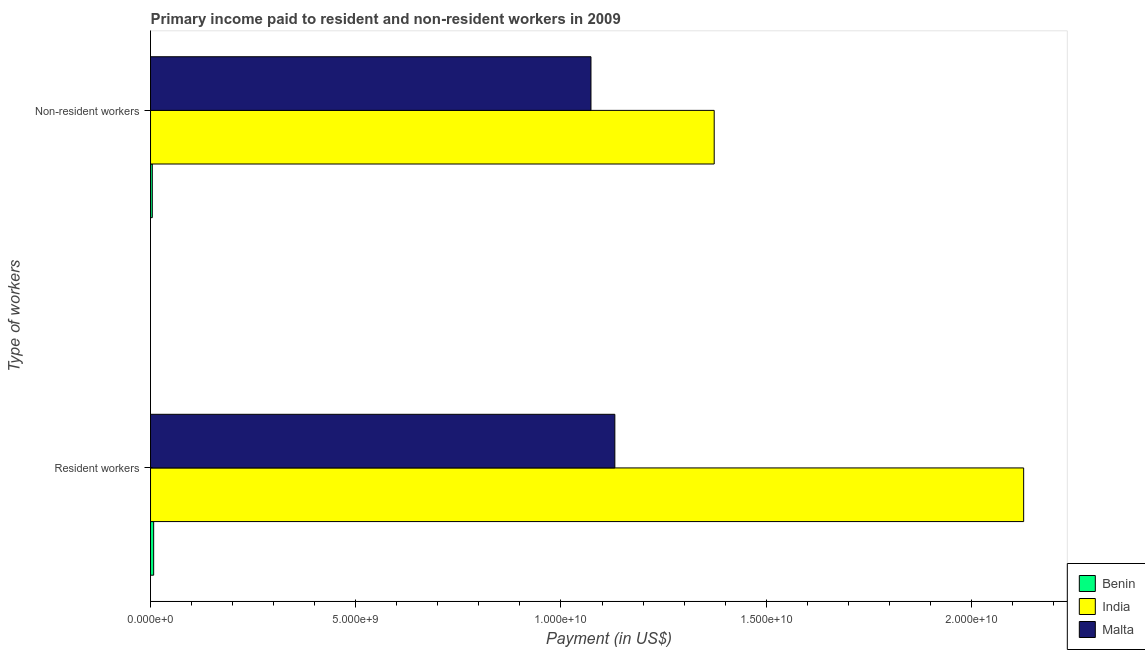Are the number of bars per tick equal to the number of legend labels?
Give a very brief answer. Yes. Are the number of bars on each tick of the Y-axis equal?
Your answer should be compact. Yes. How many bars are there on the 1st tick from the top?
Offer a terse response. 3. What is the label of the 2nd group of bars from the top?
Give a very brief answer. Resident workers. What is the payment made to resident workers in Malta?
Your answer should be compact. 1.13e+1. Across all countries, what is the maximum payment made to non-resident workers?
Provide a succinct answer. 1.37e+1. Across all countries, what is the minimum payment made to non-resident workers?
Offer a terse response. 4.31e+07. In which country was the payment made to non-resident workers minimum?
Your answer should be compact. Benin. What is the total payment made to resident workers in the graph?
Your answer should be compact. 3.27e+1. What is the difference between the payment made to resident workers in Malta and that in Benin?
Provide a short and direct response. 1.12e+1. What is the difference between the payment made to resident workers in India and the payment made to non-resident workers in Malta?
Your response must be concise. 1.05e+1. What is the average payment made to resident workers per country?
Give a very brief answer. 1.09e+1. What is the difference between the payment made to non-resident workers and payment made to resident workers in Malta?
Provide a succinct answer. -5.82e+08. What is the ratio of the payment made to resident workers in Malta to that in Benin?
Your response must be concise. 148.67. Is the payment made to non-resident workers in Benin less than that in Malta?
Your response must be concise. Yes. In how many countries, is the payment made to resident workers greater than the average payment made to resident workers taken over all countries?
Your response must be concise. 2. What does the 3rd bar from the bottom in Non-resident workers represents?
Offer a terse response. Malta. How many bars are there?
Your answer should be very brief. 6. What is the difference between two consecutive major ticks on the X-axis?
Give a very brief answer. 5.00e+09. Does the graph contain grids?
Ensure brevity in your answer.  No. What is the title of the graph?
Your answer should be compact. Primary income paid to resident and non-resident workers in 2009. What is the label or title of the X-axis?
Your answer should be very brief. Payment (in US$). What is the label or title of the Y-axis?
Make the answer very short. Type of workers. What is the Payment (in US$) of Benin in Resident workers?
Your answer should be compact. 7.61e+07. What is the Payment (in US$) of India in Resident workers?
Provide a succinct answer. 2.13e+1. What is the Payment (in US$) in Malta in Resident workers?
Offer a terse response. 1.13e+1. What is the Payment (in US$) in Benin in Non-resident workers?
Offer a terse response. 4.31e+07. What is the Payment (in US$) of India in Non-resident workers?
Give a very brief answer. 1.37e+1. What is the Payment (in US$) in Malta in Non-resident workers?
Make the answer very short. 1.07e+1. Across all Type of workers, what is the maximum Payment (in US$) in Benin?
Offer a terse response. 7.61e+07. Across all Type of workers, what is the maximum Payment (in US$) of India?
Make the answer very short. 2.13e+1. Across all Type of workers, what is the maximum Payment (in US$) in Malta?
Give a very brief answer. 1.13e+1. Across all Type of workers, what is the minimum Payment (in US$) in Benin?
Keep it short and to the point. 4.31e+07. Across all Type of workers, what is the minimum Payment (in US$) of India?
Give a very brief answer. 1.37e+1. Across all Type of workers, what is the minimum Payment (in US$) of Malta?
Ensure brevity in your answer.  1.07e+1. What is the total Payment (in US$) of Benin in the graph?
Provide a succinct answer. 1.19e+08. What is the total Payment (in US$) of India in the graph?
Provide a short and direct response. 3.50e+1. What is the total Payment (in US$) in Malta in the graph?
Provide a succinct answer. 2.20e+1. What is the difference between the Payment (in US$) in Benin in Resident workers and that in Non-resident workers?
Offer a very short reply. 3.30e+07. What is the difference between the Payment (in US$) in India in Resident workers and that in Non-resident workers?
Offer a very short reply. 7.54e+09. What is the difference between the Payment (in US$) in Malta in Resident workers and that in Non-resident workers?
Ensure brevity in your answer.  5.82e+08. What is the difference between the Payment (in US$) of Benin in Resident workers and the Payment (in US$) of India in Non-resident workers?
Offer a terse response. -1.37e+1. What is the difference between the Payment (in US$) of Benin in Resident workers and the Payment (in US$) of Malta in Non-resident workers?
Offer a terse response. -1.07e+1. What is the difference between the Payment (in US$) of India in Resident workers and the Payment (in US$) of Malta in Non-resident workers?
Keep it short and to the point. 1.05e+1. What is the average Payment (in US$) of Benin per Type of workers?
Your response must be concise. 5.96e+07. What is the average Payment (in US$) in India per Type of workers?
Give a very brief answer. 1.75e+1. What is the average Payment (in US$) in Malta per Type of workers?
Ensure brevity in your answer.  1.10e+1. What is the difference between the Payment (in US$) of Benin and Payment (in US$) of India in Resident workers?
Make the answer very short. -2.12e+1. What is the difference between the Payment (in US$) of Benin and Payment (in US$) of Malta in Resident workers?
Make the answer very short. -1.12e+1. What is the difference between the Payment (in US$) of India and Payment (in US$) of Malta in Resident workers?
Give a very brief answer. 9.96e+09. What is the difference between the Payment (in US$) in Benin and Payment (in US$) in India in Non-resident workers?
Provide a short and direct response. -1.37e+1. What is the difference between the Payment (in US$) in Benin and Payment (in US$) in Malta in Non-resident workers?
Ensure brevity in your answer.  -1.07e+1. What is the difference between the Payment (in US$) in India and Payment (in US$) in Malta in Non-resident workers?
Keep it short and to the point. 3.00e+09. What is the ratio of the Payment (in US$) in Benin in Resident workers to that in Non-resident workers?
Your answer should be very brief. 1.77. What is the ratio of the Payment (in US$) of India in Resident workers to that in Non-resident workers?
Make the answer very short. 1.55. What is the ratio of the Payment (in US$) of Malta in Resident workers to that in Non-resident workers?
Provide a short and direct response. 1.05. What is the difference between the highest and the second highest Payment (in US$) in Benin?
Your answer should be very brief. 3.30e+07. What is the difference between the highest and the second highest Payment (in US$) of India?
Your response must be concise. 7.54e+09. What is the difference between the highest and the second highest Payment (in US$) in Malta?
Keep it short and to the point. 5.82e+08. What is the difference between the highest and the lowest Payment (in US$) of Benin?
Your response must be concise. 3.30e+07. What is the difference between the highest and the lowest Payment (in US$) in India?
Make the answer very short. 7.54e+09. What is the difference between the highest and the lowest Payment (in US$) in Malta?
Your answer should be compact. 5.82e+08. 